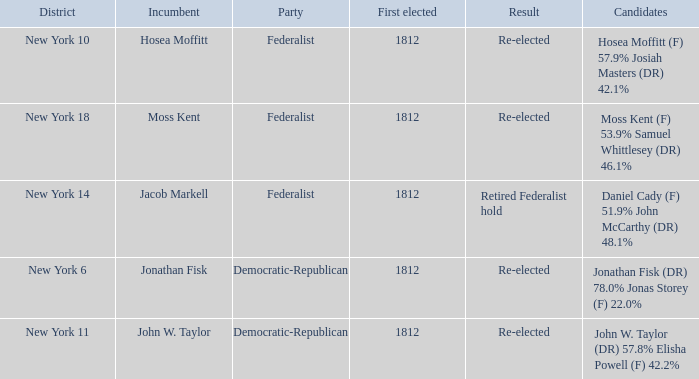Parse the full table. {'header': ['District', 'Incumbent', 'Party', 'First elected', 'Result', 'Candidates'], 'rows': [['New York 10', 'Hosea Moffitt', 'Federalist', '1812', 'Re-elected', 'Hosea Moffitt (F) 57.9% Josiah Masters (DR) 42.1%'], ['New York 18', 'Moss Kent', 'Federalist', '1812', 'Re-elected', 'Moss Kent (F) 53.9% Samuel Whittlesey (DR) 46.1%'], ['New York 14', 'Jacob Markell', 'Federalist', '1812', 'Retired Federalist hold', 'Daniel Cady (F) 51.9% John McCarthy (DR) 48.1%'], ['New York 6', 'Jonathan Fisk', 'Democratic-Republican', '1812', 'Re-elected', 'Jonathan Fisk (DR) 78.0% Jonas Storey (F) 22.0%'], ['New York 11', 'John W. Taylor', 'Democratic-Republican', '1812', 'Re-elected', 'John W. Taylor (DR) 57.8% Elisha Powell (F) 42.2%']]} Name the most first elected 1812.0. 